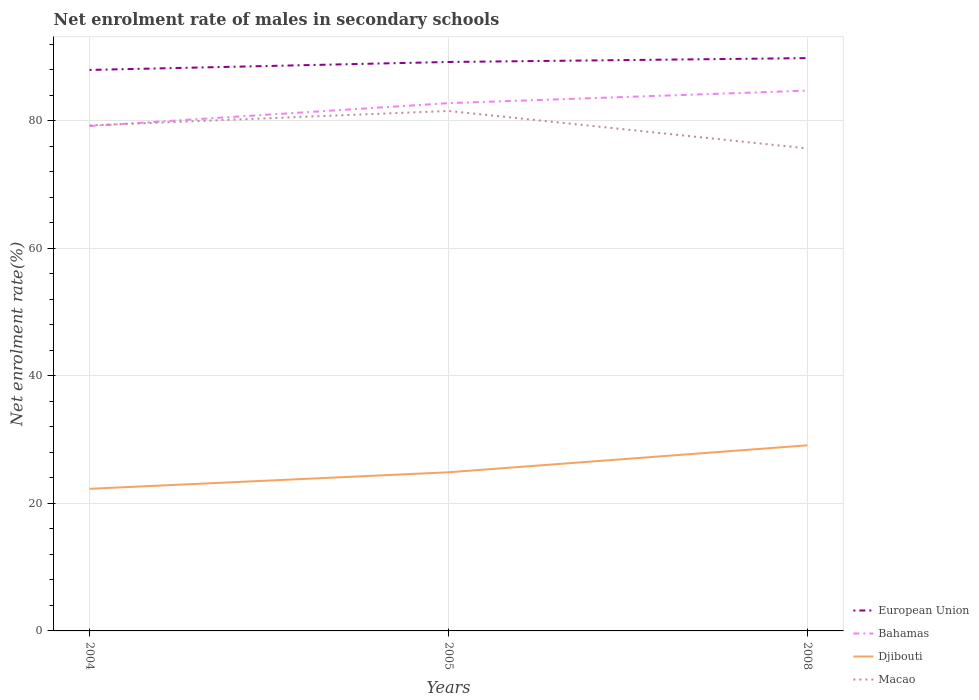Across all years, what is the maximum net enrolment rate of males in secondary schools in Bahamas?
Your response must be concise. 79.19. What is the total net enrolment rate of males in secondary schools in Macao in the graph?
Your answer should be compact. 5.87. What is the difference between the highest and the second highest net enrolment rate of males in secondary schools in European Union?
Your answer should be compact. 1.85. Is the net enrolment rate of males in secondary schools in European Union strictly greater than the net enrolment rate of males in secondary schools in Bahamas over the years?
Ensure brevity in your answer.  No. Does the graph contain any zero values?
Keep it short and to the point. No. How many legend labels are there?
Keep it short and to the point. 4. How are the legend labels stacked?
Provide a short and direct response. Vertical. What is the title of the graph?
Provide a short and direct response. Net enrolment rate of males in secondary schools. Does "Yemen, Rep." appear as one of the legend labels in the graph?
Your answer should be compact. No. What is the label or title of the X-axis?
Provide a succinct answer. Years. What is the label or title of the Y-axis?
Make the answer very short. Net enrolment rate(%). What is the Net enrolment rate(%) in European Union in 2004?
Provide a succinct answer. 87.99. What is the Net enrolment rate(%) in Bahamas in 2004?
Offer a terse response. 79.19. What is the Net enrolment rate(%) of Djibouti in 2004?
Your response must be concise. 22.29. What is the Net enrolment rate(%) in Macao in 2004?
Your answer should be very brief. 79.29. What is the Net enrolment rate(%) of European Union in 2005?
Provide a short and direct response. 89.24. What is the Net enrolment rate(%) in Bahamas in 2005?
Provide a short and direct response. 82.78. What is the Net enrolment rate(%) of Djibouti in 2005?
Offer a very short reply. 24.88. What is the Net enrolment rate(%) in Macao in 2005?
Your answer should be very brief. 81.56. What is the Net enrolment rate(%) in European Union in 2008?
Provide a short and direct response. 89.85. What is the Net enrolment rate(%) of Bahamas in 2008?
Your response must be concise. 84.75. What is the Net enrolment rate(%) of Djibouti in 2008?
Provide a succinct answer. 29.11. What is the Net enrolment rate(%) in Macao in 2008?
Provide a succinct answer. 75.68. Across all years, what is the maximum Net enrolment rate(%) of European Union?
Ensure brevity in your answer.  89.85. Across all years, what is the maximum Net enrolment rate(%) in Bahamas?
Offer a terse response. 84.75. Across all years, what is the maximum Net enrolment rate(%) in Djibouti?
Provide a short and direct response. 29.11. Across all years, what is the maximum Net enrolment rate(%) in Macao?
Your response must be concise. 81.56. Across all years, what is the minimum Net enrolment rate(%) of European Union?
Offer a very short reply. 87.99. Across all years, what is the minimum Net enrolment rate(%) in Bahamas?
Provide a short and direct response. 79.19. Across all years, what is the minimum Net enrolment rate(%) of Djibouti?
Keep it short and to the point. 22.29. Across all years, what is the minimum Net enrolment rate(%) of Macao?
Provide a short and direct response. 75.68. What is the total Net enrolment rate(%) in European Union in the graph?
Give a very brief answer. 267.08. What is the total Net enrolment rate(%) of Bahamas in the graph?
Your response must be concise. 246.72. What is the total Net enrolment rate(%) in Djibouti in the graph?
Keep it short and to the point. 76.29. What is the total Net enrolment rate(%) in Macao in the graph?
Provide a succinct answer. 236.53. What is the difference between the Net enrolment rate(%) of European Union in 2004 and that in 2005?
Your response must be concise. -1.25. What is the difference between the Net enrolment rate(%) of Bahamas in 2004 and that in 2005?
Make the answer very short. -3.59. What is the difference between the Net enrolment rate(%) in Djibouti in 2004 and that in 2005?
Provide a short and direct response. -2.59. What is the difference between the Net enrolment rate(%) in Macao in 2004 and that in 2005?
Provide a short and direct response. -2.27. What is the difference between the Net enrolment rate(%) in European Union in 2004 and that in 2008?
Make the answer very short. -1.85. What is the difference between the Net enrolment rate(%) in Bahamas in 2004 and that in 2008?
Your response must be concise. -5.55. What is the difference between the Net enrolment rate(%) in Djibouti in 2004 and that in 2008?
Provide a short and direct response. -6.82. What is the difference between the Net enrolment rate(%) of Macao in 2004 and that in 2008?
Keep it short and to the point. 3.6. What is the difference between the Net enrolment rate(%) of European Union in 2005 and that in 2008?
Provide a short and direct response. -0.61. What is the difference between the Net enrolment rate(%) in Bahamas in 2005 and that in 2008?
Make the answer very short. -1.96. What is the difference between the Net enrolment rate(%) in Djibouti in 2005 and that in 2008?
Ensure brevity in your answer.  -4.23. What is the difference between the Net enrolment rate(%) of Macao in 2005 and that in 2008?
Offer a very short reply. 5.87. What is the difference between the Net enrolment rate(%) in European Union in 2004 and the Net enrolment rate(%) in Bahamas in 2005?
Offer a very short reply. 5.21. What is the difference between the Net enrolment rate(%) of European Union in 2004 and the Net enrolment rate(%) of Djibouti in 2005?
Keep it short and to the point. 63.11. What is the difference between the Net enrolment rate(%) of European Union in 2004 and the Net enrolment rate(%) of Macao in 2005?
Ensure brevity in your answer.  6.44. What is the difference between the Net enrolment rate(%) of Bahamas in 2004 and the Net enrolment rate(%) of Djibouti in 2005?
Provide a short and direct response. 54.31. What is the difference between the Net enrolment rate(%) in Bahamas in 2004 and the Net enrolment rate(%) in Macao in 2005?
Ensure brevity in your answer.  -2.36. What is the difference between the Net enrolment rate(%) of Djibouti in 2004 and the Net enrolment rate(%) of Macao in 2005?
Your answer should be compact. -59.27. What is the difference between the Net enrolment rate(%) in European Union in 2004 and the Net enrolment rate(%) in Bahamas in 2008?
Offer a terse response. 3.25. What is the difference between the Net enrolment rate(%) of European Union in 2004 and the Net enrolment rate(%) of Djibouti in 2008?
Your answer should be compact. 58.88. What is the difference between the Net enrolment rate(%) in European Union in 2004 and the Net enrolment rate(%) in Macao in 2008?
Keep it short and to the point. 12.31. What is the difference between the Net enrolment rate(%) of Bahamas in 2004 and the Net enrolment rate(%) of Djibouti in 2008?
Your response must be concise. 50.08. What is the difference between the Net enrolment rate(%) in Bahamas in 2004 and the Net enrolment rate(%) in Macao in 2008?
Keep it short and to the point. 3.51. What is the difference between the Net enrolment rate(%) in Djibouti in 2004 and the Net enrolment rate(%) in Macao in 2008?
Keep it short and to the point. -53.39. What is the difference between the Net enrolment rate(%) of European Union in 2005 and the Net enrolment rate(%) of Bahamas in 2008?
Give a very brief answer. 4.49. What is the difference between the Net enrolment rate(%) in European Union in 2005 and the Net enrolment rate(%) in Djibouti in 2008?
Your answer should be very brief. 60.13. What is the difference between the Net enrolment rate(%) of European Union in 2005 and the Net enrolment rate(%) of Macao in 2008?
Provide a succinct answer. 13.56. What is the difference between the Net enrolment rate(%) of Bahamas in 2005 and the Net enrolment rate(%) of Djibouti in 2008?
Make the answer very short. 53.67. What is the difference between the Net enrolment rate(%) of Bahamas in 2005 and the Net enrolment rate(%) of Macao in 2008?
Offer a very short reply. 7.1. What is the difference between the Net enrolment rate(%) of Djibouti in 2005 and the Net enrolment rate(%) of Macao in 2008?
Offer a terse response. -50.8. What is the average Net enrolment rate(%) in European Union per year?
Your answer should be very brief. 89.03. What is the average Net enrolment rate(%) of Bahamas per year?
Ensure brevity in your answer.  82.24. What is the average Net enrolment rate(%) of Djibouti per year?
Offer a very short reply. 25.43. What is the average Net enrolment rate(%) in Macao per year?
Ensure brevity in your answer.  78.84. In the year 2004, what is the difference between the Net enrolment rate(%) of European Union and Net enrolment rate(%) of Bahamas?
Offer a terse response. 8.8. In the year 2004, what is the difference between the Net enrolment rate(%) of European Union and Net enrolment rate(%) of Djibouti?
Provide a short and direct response. 65.7. In the year 2004, what is the difference between the Net enrolment rate(%) in European Union and Net enrolment rate(%) in Macao?
Make the answer very short. 8.7. In the year 2004, what is the difference between the Net enrolment rate(%) of Bahamas and Net enrolment rate(%) of Djibouti?
Your answer should be very brief. 56.9. In the year 2004, what is the difference between the Net enrolment rate(%) in Bahamas and Net enrolment rate(%) in Macao?
Provide a succinct answer. -0.1. In the year 2004, what is the difference between the Net enrolment rate(%) of Djibouti and Net enrolment rate(%) of Macao?
Offer a very short reply. -57. In the year 2005, what is the difference between the Net enrolment rate(%) of European Union and Net enrolment rate(%) of Bahamas?
Offer a very short reply. 6.46. In the year 2005, what is the difference between the Net enrolment rate(%) of European Union and Net enrolment rate(%) of Djibouti?
Your response must be concise. 64.36. In the year 2005, what is the difference between the Net enrolment rate(%) of European Union and Net enrolment rate(%) of Macao?
Give a very brief answer. 7.68. In the year 2005, what is the difference between the Net enrolment rate(%) in Bahamas and Net enrolment rate(%) in Djibouti?
Offer a terse response. 57.9. In the year 2005, what is the difference between the Net enrolment rate(%) of Bahamas and Net enrolment rate(%) of Macao?
Provide a short and direct response. 1.23. In the year 2005, what is the difference between the Net enrolment rate(%) of Djibouti and Net enrolment rate(%) of Macao?
Keep it short and to the point. -56.67. In the year 2008, what is the difference between the Net enrolment rate(%) of European Union and Net enrolment rate(%) of Djibouti?
Provide a succinct answer. 60.73. In the year 2008, what is the difference between the Net enrolment rate(%) of European Union and Net enrolment rate(%) of Macao?
Provide a short and direct response. 14.16. In the year 2008, what is the difference between the Net enrolment rate(%) of Bahamas and Net enrolment rate(%) of Djibouti?
Make the answer very short. 55.63. In the year 2008, what is the difference between the Net enrolment rate(%) in Bahamas and Net enrolment rate(%) in Macao?
Your answer should be compact. 9.06. In the year 2008, what is the difference between the Net enrolment rate(%) in Djibouti and Net enrolment rate(%) in Macao?
Keep it short and to the point. -46.57. What is the ratio of the Net enrolment rate(%) in Bahamas in 2004 to that in 2005?
Keep it short and to the point. 0.96. What is the ratio of the Net enrolment rate(%) of Djibouti in 2004 to that in 2005?
Keep it short and to the point. 0.9. What is the ratio of the Net enrolment rate(%) of Macao in 2004 to that in 2005?
Offer a very short reply. 0.97. What is the ratio of the Net enrolment rate(%) of European Union in 2004 to that in 2008?
Your response must be concise. 0.98. What is the ratio of the Net enrolment rate(%) in Bahamas in 2004 to that in 2008?
Keep it short and to the point. 0.93. What is the ratio of the Net enrolment rate(%) of Djibouti in 2004 to that in 2008?
Provide a short and direct response. 0.77. What is the ratio of the Net enrolment rate(%) of Macao in 2004 to that in 2008?
Your answer should be very brief. 1.05. What is the ratio of the Net enrolment rate(%) of Bahamas in 2005 to that in 2008?
Provide a short and direct response. 0.98. What is the ratio of the Net enrolment rate(%) in Djibouti in 2005 to that in 2008?
Offer a very short reply. 0.85. What is the ratio of the Net enrolment rate(%) of Macao in 2005 to that in 2008?
Your response must be concise. 1.08. What is the difference between the highest and the second highest Net enrolment rate(%) of European Union?
Your answer should be very brief. 0.61. What is the difference between the highest and the second highest Net enrolment rate(%) in Bahamas?
Provide a short and direct response. 1.96. What is the difference between the highest and the second highest Net enrolment rate(%) in Djibouti?
Your response must be concise. 4.23. What is the difference between the highest and the second highest Net enrolment rate(%) of Macao?
Keep it short and to the point. 2.27. What is the difference between the highest and the lowest Net enrolment rate(%) in European Union?
Provide a succinct answer. 1.85. What is the difference between the highest and the lowest Net enrolment rate(%) of Bahamas?
Provide a short and direct response. 5.55. What is the difference between the highest and the lowest Net enrolment rate(%) in Djibouti?
Keep it short and to the point. 6.82. What is the difference between the highest and the lowest Net enrolment rate(%) of Macao?
Your response must be concise. 5.87. 